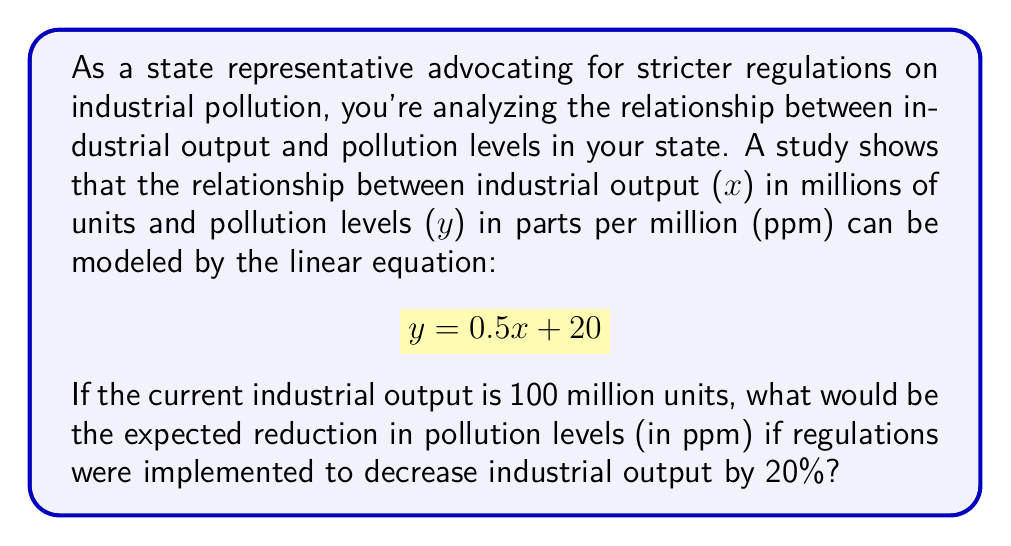Give your solution to this math problem. To solve this problem, we'll follow these steps:

1. Calculate the current pollution level:
   - Current industrial output: $x = 100$ million units
   - Using the equation $y = 0.5x + 20$:
   $$ y = 0.5(100) + 20 = 50 + 20 = 70 \text{ ppm} $$

2. Calculate the new industrial output after 20% reduction:
   - 20% of 100 million units is $0.2 \times 100 = 20$ million units
   - New output: $100 - 20 = 80$ million units

3. Calculate the new pollution level:
   $$ y = 0.5(80) + 20 = 40 + 20 = 60 \text{ ppm} $$

4. Calculate the reduction in pollution levels:
   $$ \text{Reduction} = 70 \text{ ppm} - 60 \text{ ppm} = 10 \text{ ppm} $$

Therefore, implementing regulations to decrease industrial output by 20% would result in a 10 ppm reduction in pollution levels.
Answer: The expected reduction in pollution levels would be 10 ppm. 